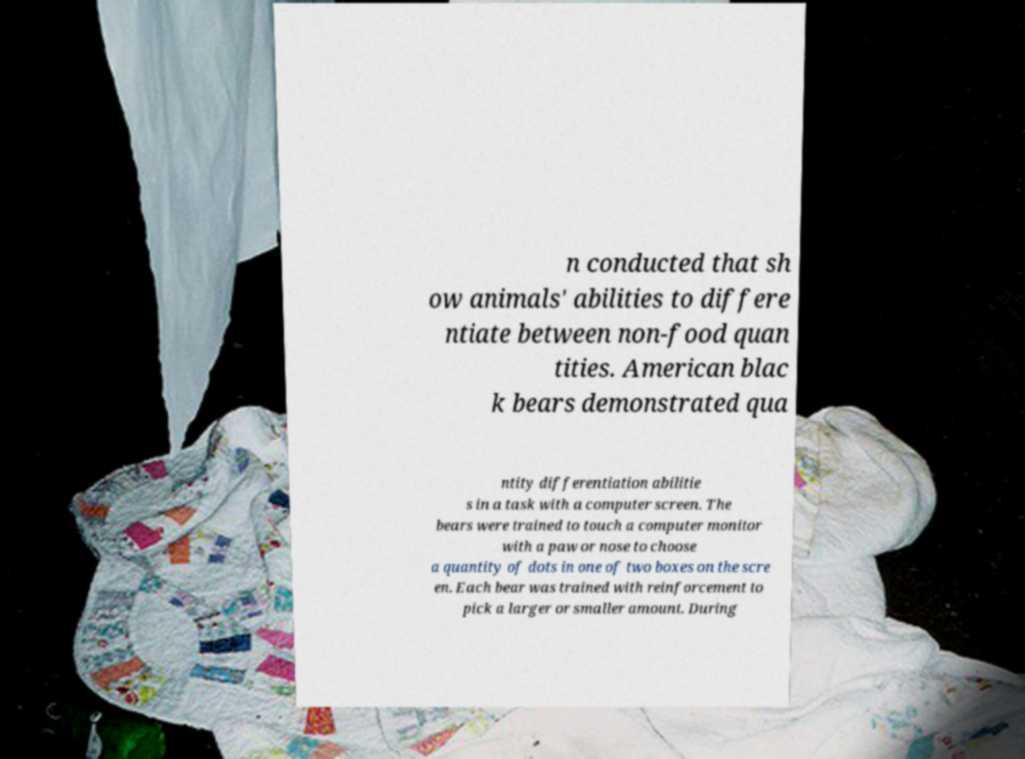Could you extract and type out the text from this image? n conducted that sh ow animals' abilities to differe ntiate between non-food quan tities. American blac k bears demonstrated qua ntity differentiation abilitie s in a task with a computer screen. The bears were trained to touch a computer monitor with a paw or nose to choose a quantity of dots in one of two boxes on the scre en. Each bear was trained with reinforcement to pick a larger or smaller amount. During 